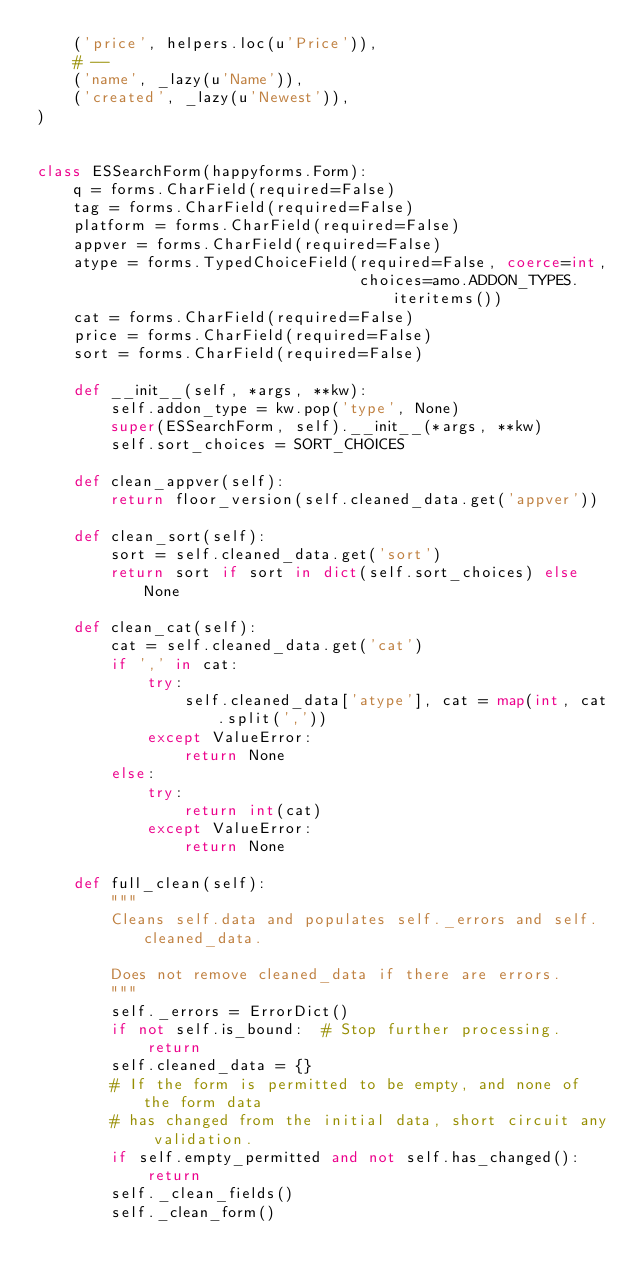Convert code to text. <code><loc_0><loc_0><loc_500><loc_500><_Python_>    ('price', helpers.loc(u'Price')),
    # --
    ('name', _lazy(u'Name')),
    ('created', _lazy(u'Newest')),
)


class ESSearchForm(happyforms.Form):
    q = forms.CharField(required=False)
    tag = forms.CharField(required=False)
    platform = forms.CharField(required=False)
    appver = forms.CharField(required=False)
    atype = forms.TypedChoiceField(required=False, coerce=int,
                                   choices=amo.ADDON_TYPES.iteritems())
    cat = forms.CharField(required=False)
    price = forms.CharField(required=False)
    sort = forms.CharField(required=False)

    def __init__(self, *args, **kw):
        self.addon_type = kw.pop('type', None)
        super(ESSearchForm, self).__init__(*args, **kw)
        self.sort_choices = SORT_CHOICES

    def clean_appver(self):
        return floor_version(self.cleaned_data.get('appver'))

    def clean_sort(self):
        sort = self.cleaned_data.get('sort')
        return sort if sort in dict(self.sort_choices) else None

    def clean_cat(self):
        cat = self.cleaned_data.get('cat')
        if ',' in cat:
            try:
                self.cleaned_data['atype'], cat = map(int, cat.split(','))
            except ValueError:
                return None
        else:
            try:
                return int(cat)
            except ValueError:
                return None

    def full_clean(self):
        """
        Cleans self.data and populates self._errors and self.cleaned_data.

        Does not remove cleaned_data if there are errors.
        """
        self._errors = ErrorDict()
        if not self.is_bound:  # Stop further processing.
            return
        self.cleaned_data = {}
        # If the form is permitted to be empty, and none of the form data
        # has changed from the initial data, short circuit any validation.
        if self.empty_permitted and not self.has_changed():
            return
        self._clean_fields()
        self._clean_form()
</code> 